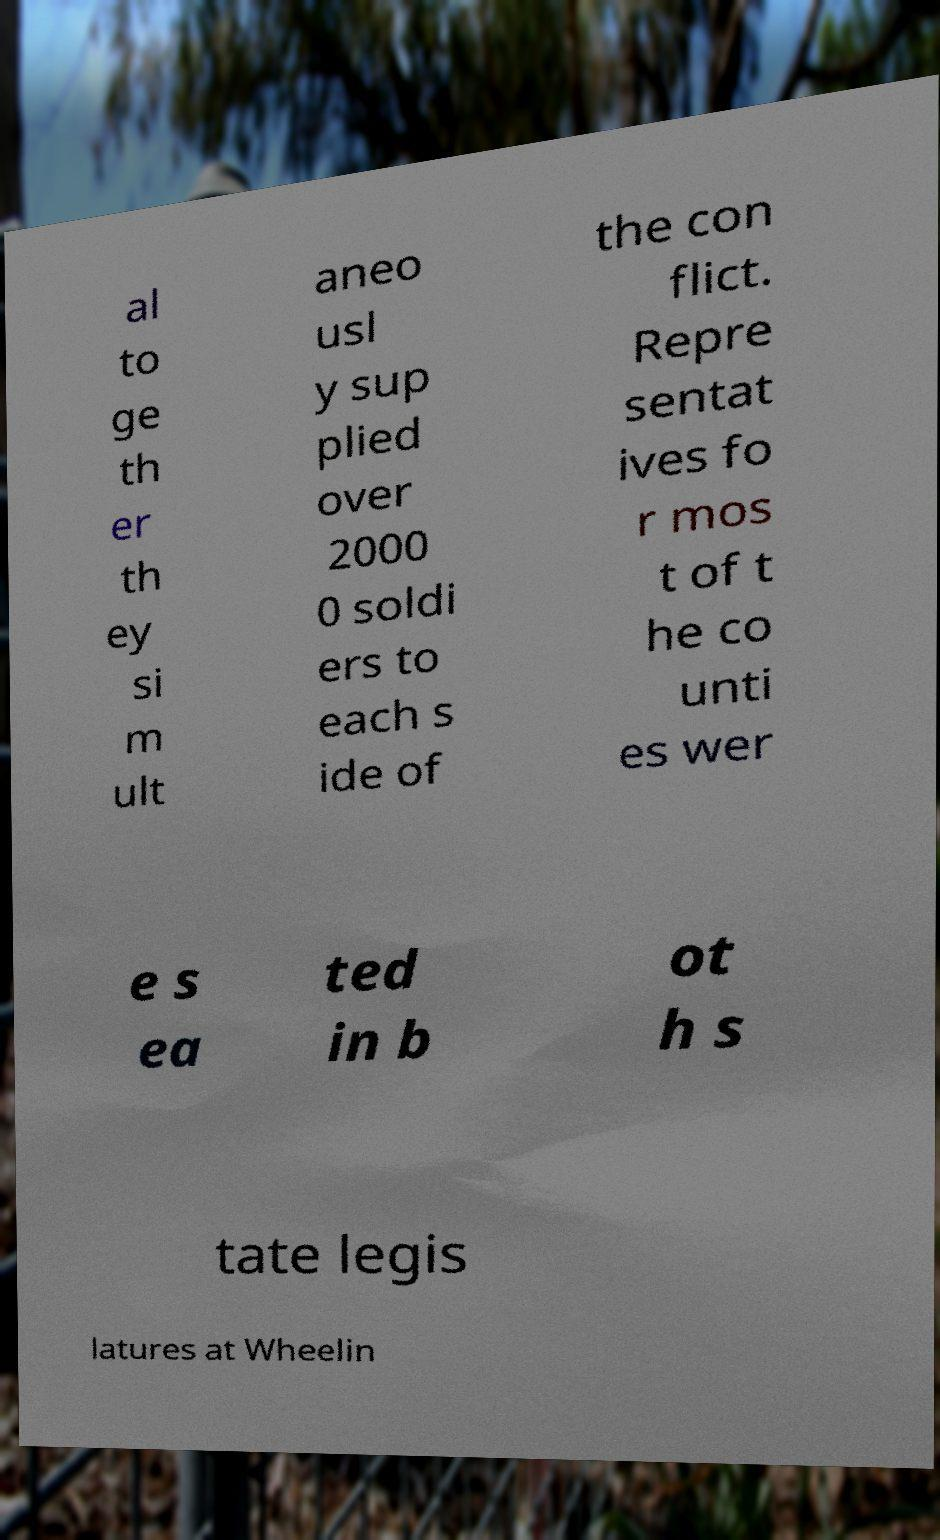Could you assist in decoding the text presented in this image and type it out clearly? al to ge th er th ey si m ult aneo usl y sup plied over 2000 0 soldi ers to each s ide of the con flict. Repre sentat ives fo r mos t of t he co unti es wer e s ea ted in b ot h s tate legis latures at Wheelin 